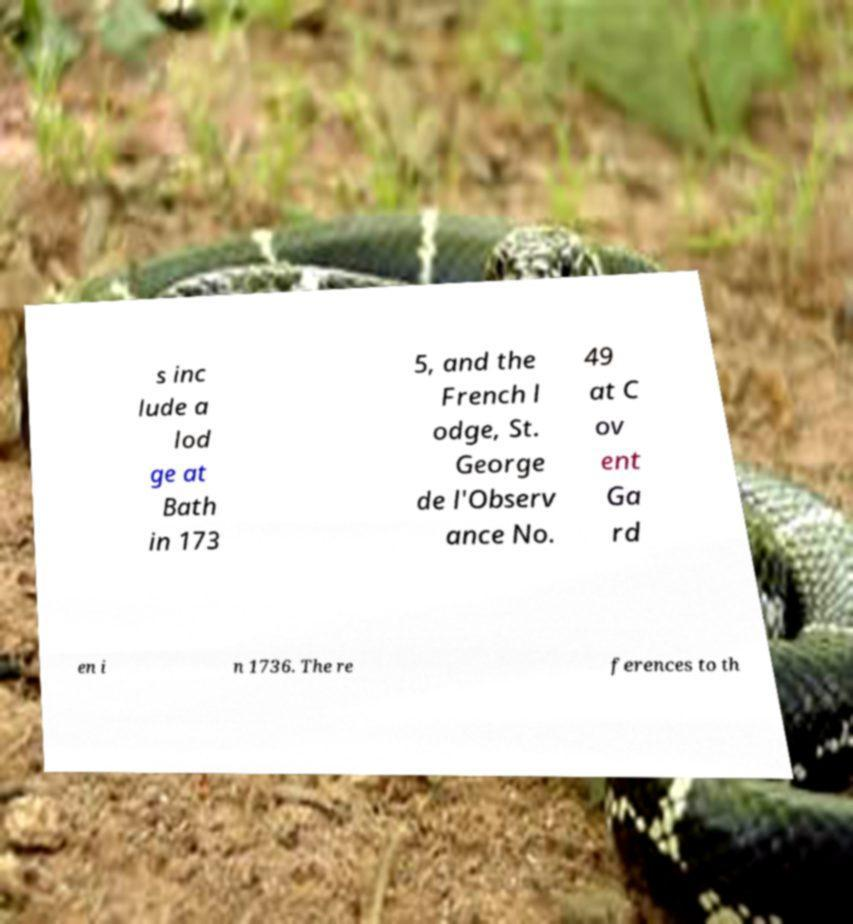Can you read and provide the text displayed in the image?This photo seems to have some interesting text. Can you extract and type it out for me? s inc lude a lod ge at Bath in 173 5, and the French l odge, St. George de l'Observ ance No. 49 at C ov ent Ga rd en i n 1736. The re ferences to th 